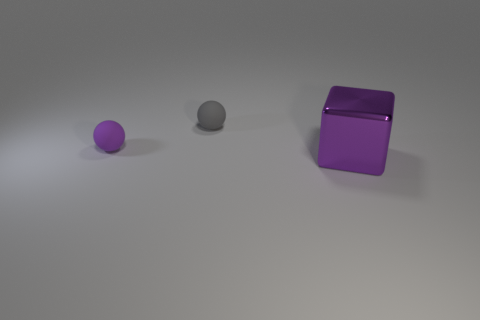Is the material of the tiny object in front of the tiny gray rubber object the same as the tiny thing to the right of the tiny purple rubber object?
Offer a very short reply. Yes. What number of tiny things are either purple rubber objects or spheres?
Offer a very short reply. 2. What shape is the tiny purple thing that is made of the same material as the gray sphere?
Provide a short and direct response. Sphere. Is the number of big purple metal blocks to the left of the small gray matte thing less than the number of purple rubber things?
Your answer should be very brief. Yes. Is the small purple object the same shape as the tiny gray rubber thing?
Offer a very short reply. Yes. What number of rubber things are either tiny objects or big cyan balls?
Your answer should be very brief. 2. Are there any red metal things of the same size as the gray rubber thing?
Offer a terse response. No. What is the shape of the other object that is the same color as the big object?
Offer a very short reply. Sphere. What number of gray rubber objects have the same size as the gray matte ball?
Give a very brief answer. 0. Do the matte object to the right of the purple rubber sphere and the object that is in front of the small purple matte thing have the same size?
Keep it short and to the point. No. 